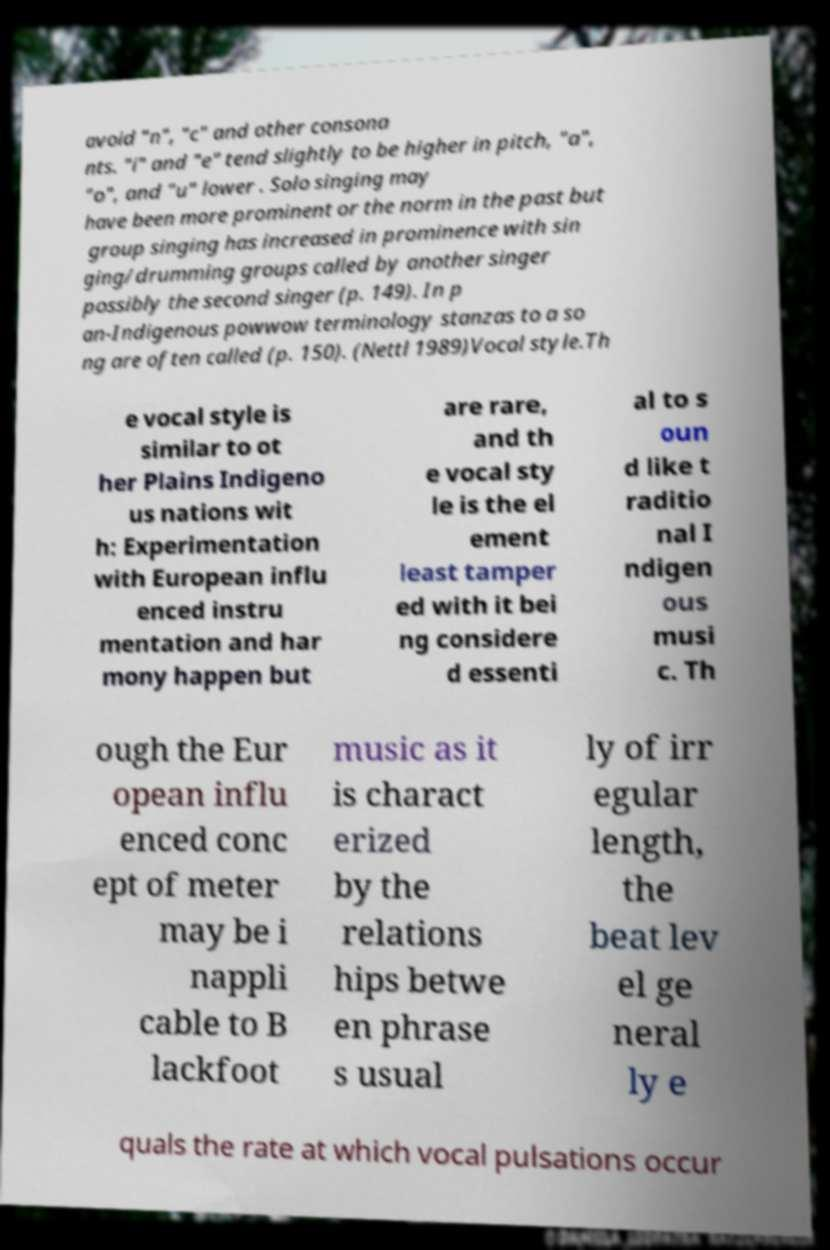Could you assist in decoding the text presented in this image and type it out clearly? avoid "n", "c" and other consona nts. "i" and "e" tend slightly to be higher in pitch, "a", "o", and "u" lower . Solo singing may have been more prominent or the norm in the past but group singing has increased in prominence with sin ging/drumming groups called by another singer possibly the second singer (p. 149). In p an-Indigenous powwow terminology stanzas to a so ng are often called (p. 150). (Nettl 1989)Vocal style.Th e vocal style is similar to ot her Plains Indigeno us nations wit h: Experimentation with European influ enced instru mentation and har mony happen but are rare, and th e vocal sty le is the el ement least tamper ed with it bei ng considere d essenti al to s oun d like t raditio nal I ndigen ous musi c. Th ough the Eur opean influ enced conc ept of meter may be i nappli cable to B lackfoot music as it is charact erized by the relations hips betwe en phrase s usual ly of irr egular length, the beat lev el ge neral ly e quals the rate at which vocal pulsations occur 